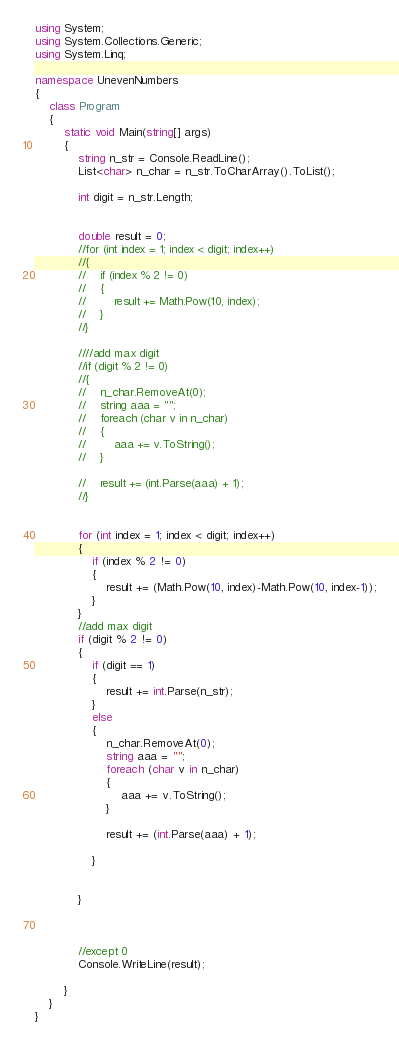<code> <loc_0><loc_0><loc_500><loc_500><_C#_>using System;
using System.Collections.Generic;
using System.Linq;

namespace UnevenNumbers
{
    class Program
    {
        static void Main(string[] args)
        {
            string n_str = Console.ReadLine();
            List<char> n_char = n_str.ToCharArray().ToList();

            int digit = n_str.Length;


            double result = 0;
            //for (int index = 1; index < digit; index++)
            //{
            //    if (index % 2 != 0)
            //    {
            //        result += Math.Pow(10, index);
            //    }
            //}

            ////add max digit
            //if (digit % 2 != 0)
            //{
            //    n_char.RemoveAt(0);
            //    string aaa = "";
            //    foreach (char v in n_char)
            //    {
            //        aaa += v.ToString();
            //    }

            //    result += (int.Parse(aaa) + 1);
            //}


            for (int index = 1; index < digit; index++)
            {
                if (index % 2 != 0)
                {
                    result += (Math.Pow(10, index)-Math.Pow(10, index-1));
                }
            }
            //add max digit
            if (digit % 2 != 0)
            {
                if (digit == 1)
                {
                    result += int.Parse(n_str);
                }
                else
                {
                    n_char.RemoveAt(0);
                    string aaa = "";
                    foreach (char v in n_char)
                    {
                        aaa += v.ToString();
                    }

                    result += (int.Parse(aaa) + 1);

                }


            }



            //except 0
            Console.WriteLine(result);

        }
    }
}
</code> 